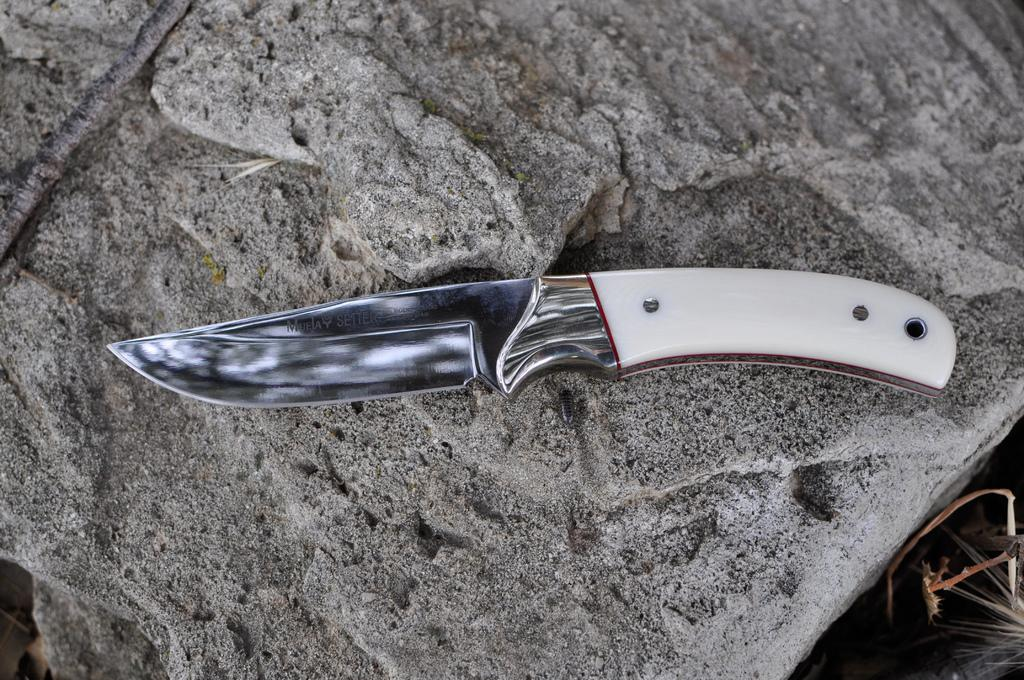What object can be seen in the image? There is a knife in the image. Where is the knife located? The knife is on a rock. What type of train can be seen in the image? There is no train present in the image; it only features a knife on a rock. What kind of apparatus is used to limit the knife's movement in the image? There is no apparatus present in the image to limit the knife's movement, as it is simply resting on a rock. 